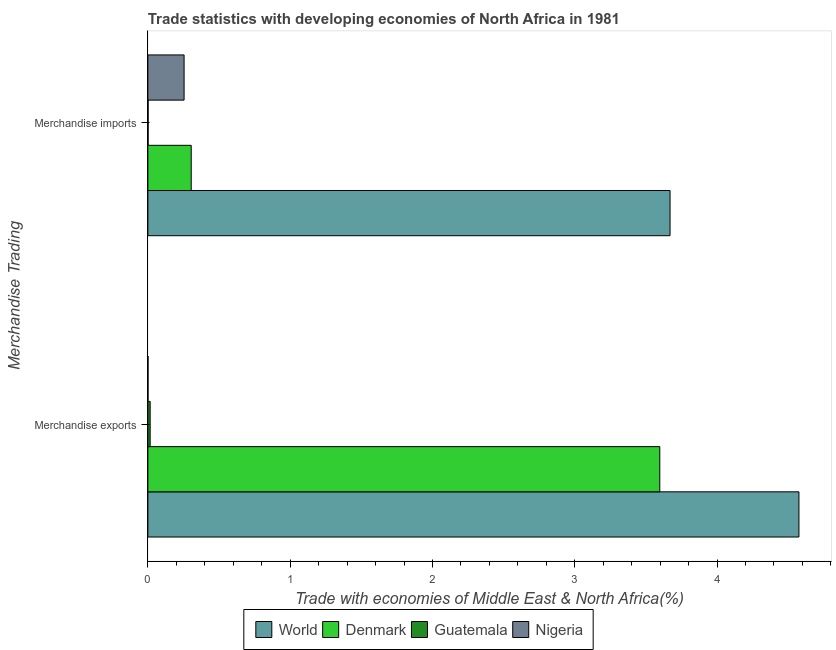How many groups of bars are there?
Provide a succinct answer. 2. Are the number of bars on each tick of the Y-axis equal?
Offer a terse response. Yes. How many bars are there on the 1st tick from the bottom?
Your answer should be very brief. 4. What is the label of the 2nd group of bars from the top?
Ensure brevity in your answer.  Merchandise exports. What is the merchandise exports in World?
Offer a terse response. 4.58. Across all countries, what is the maximum merchandise imports?
Make the answer very short. 3.67. Across all countries, what is the minimum merchandise exports?
Give a very brief answer. 0. In which country was the merchandise exports minimum?
Offer a very short reply. Nigeria. What is the total merchandise exports in the graph?
Provide a short and direct response. 8.19. What is the difference between the merchandise exports in Nigeria and that in World?
Your answer should be very brief. -4.57. What is the difference between the merchandise exports in Guatemala and the merchandise imports in Nigeria?
Offer a terse response. -0.24. What is the average merchandise exports per country?
Ensure brevity in your answer.  2.05. What is the difference between the merchandise imports and merchandise exports in Denmark?
Make the answer very short. -3.29. What is the ratio of the merchandise exports in Nigeria to that in Guatemala?
Offer a terse response. 0.06. What does the 3rd bar from the bottom in Merchandise imports represents?
Provide a succinct answer. Guatemala. How many bars are there?
Provide a succinct answer. 8. Does the graph contain any zero values?
Keep it short and to the point. No. Does the graph contain grids?
Your response must be concise. No. What is the title of the graph?
Give a very brief answer. Trade statistics with developing economies of North Africa in 1981. What is the label or title of the X-axis?
Your answer should be very brief. Trade with economies of Middle East & North Africa(%). What is the label or title of the Y-axis?
Make the answer very short. Merchandise Trading. What is the Trade with economies of Middle East & North Africa(%) of World in Merchandise exports?
Provide a short and direct response. 4.58. What is the Trade with economies of Middle East & North Africa(%) in Denmark in Merchandise exports?
Provide a short and direct response. 3.6. What is the Trade with economies of Middle East & North Africa(%) of Guatemala in Merchandise exports?
Provide a short and direct response. 0.02. What is the Trade with economies of Middle East & North Africa(%) in Nigeria in Merchandise exports?
Keep it short and to the point. 0. What is the Trade with economies of Middle East & North Africa(%) of World in Merchandise imports?
Provide a succinct answer. 3.67. What is the Trade with economies of Middle East & North Africa(%) of Denmark in Merchandise imports?
Your answer should be very brief. 0.3. What is the Trade with economies of Middle East & North Africa(%) of Guatemala in Merchandise imports?
Your answer should be very brief. 0. What is the Trade with economies of Middle East & North Africa(%) in Nigeria in Merchandise imports?
Make the answer very short. 0.25. Across all Merchandise Trading, what is the maximum Trade with economies of Middle East & North Africa(%) in World?
Your response must be concise. 4.58. Across all Merchandise Trading, what is the maximum Trade with economies of Middle East & North Africa(%) of Denmark?
Keep it short and to the point. 3.6. Across all Merchandise Trading, what is the maximum Trade with economies of Middle East & North Africa(%) in Guatemala?
Ensure brevity in your answer.  0.02. Across all Merchandise Trading, what is the maximum Trade with economies of Middle East & North Africa(%) in Nigeria?
Provide a succinct answer. 0.25. Across all Merchandise Trading, what is the minimum Trade with economies of Middle East & North Africa(%) of World?
Make the answer very short. 3.67. Across all Merchandise Trading, what is the minimum Trade with economies of Middle East & North Africa(%) in Denmark?
Give a very brief answer. 0.3. Across all Merchandise Trading, what is the minimum Trade with economies of Middle East & North Africa(%) of Guatemala?
Ensure brevity in your answer.  0. Across all Merchandise Trading, what is the minimum Trade with economies of Middle East & North Africa(%) in Nigeria?
Your answer should be compact. 0. What is the total Trade with economies of Middle East & North Africa(%) of World in the graph?
Your answer should be very brief. 8.24. What is the total Trade with economies of Middle East & North Africa(%) in Denmark in the graph?
Your answer should be compact. 3.9. What is the total Trade with economies of Middle East & North Africa(%) of Guatemala in the graph?
Your response must be concise. 0.02. What is the total Trade with economies of Middle East & North Africa(%) of Nigeria in the graph?
Provide a short and direct response. 0.26. What is the difference between the Trade with economies of Middle East & North Africa(%) in World in Merchandise exports and that in Merchandise imports?
Provide a succinct answer. 0.91. What is the difference between the Trade with economies of Middle East & North Africa(%) in Denmark in Merchandise exports and that in Merchandise imports?
Provide a succinct answer. 3.29. What is the difference between the Trade with economies of Middle East & North Africa(%) of Guatemala in Merchandise exports and that in Merchandise imports?
Your answer should be compact. 0.01. What is the difference between the Trade with economies of Middle East & North Africa(%) of Nigeria in Merchandise exports and that in Merchandise imports?
Give a very brief answer. -0.25. What is the difference between the Trade with economies of Middle East & North Africa(%) in World in Merchandise exports and the Trade with economies of Middle East & North Africa(%) in Denmark in Merchandise imports?
Offer a terse response. 4.27. What is the difference between the Trade with economies of Middle East & North Africa(%) of World in Merchandise exports and the Trade with economies of Middle East & North Africa(%) of Guatemala in Merchandise imports?
Offer a terse response. 4.57. What is the difference between the Trade with economies of Middle East & North Africa(%) of World in Merchandise exports and the Trade with economies of Middle East & North Africa(%) of Nigeria in Merchandise imports?
Offer a very short reply. 4.32. What is the difference between the Trade with economies of Middle East & North Africa(%) of Denmark in Merchandise exports and the Trade with economies of Middle East & North Africa(%) of Guatemala in Merchandise imports?
Give a very brief answer. 3.6. What is the difference between the Trade with economies of Middle East & North Africa(%) of Denmark in Merchandise exports and the Trade with economies of Middle East & North Africa(%) of Nigeria in Merchandise imports?
Offer a very short reply. 3.34. What is the difference between the Trade with economies of Middle East & North Africa(%) in Guatemala in Merchandise exports and the Trade with economies of Middle East & North Africa(%) in Nigeria in Merchandise imports?
Keep it short and to the point. -0.24. What is the average Trade with economies of Middle East & North Africa(%) in World per Merchandise Trading?
Your answer should be very brief. 4.12. What is the average Trade with economies of Middle East & North Africa(%) in Denmark per Merchandise Trading?
Your answer should be very brief. 1.95. What is the average Trade with economies of Middle East & North Africa(%) in Guatemala per Merchandise Trading?
Offer a very short reply. 0.01. What is the average Trade with economies of Middle East & North Africa(%) in Nigeria per Merchandise Trading?
Your answer should be very brief. 0.13. What is the difference between the Trade with economies of Middle East & North Africa(%) of World and Trade with economies of Middle East & North Africa(%) of Guatemala in Merchandise exports?
Your answer should be very brief. 4.56. What is the difference between the Trade with economies of Middle East & North Africa(%) in World and Trade with economies of Middle East & North Africa(%) in Nigeria in Merchandise exports?
Provide a succinct answer. 4.57. What is the difference between the Trade with economies of Middle East & North Africa(%) of Denmark and Trade with economies of Middle East & North Africa(%) of Guatemala in Merchandise exports?
Provide a succinct answer. 3.58. What is the difference between the Trade with economies of Middle East & North Africa(%) in Denmark and Trade with economies of Middle East & North Africa(%) in Nigeria in Merchandise exports?
Your response must be concise. 3.6. What is the difference between the Trade with economies of Middle East & North Africa(%) of Guatemala and Trade with economies of Middle East & North Africa(%) of Nigeria in Merchandise exports?
Provide a short and direct response. 0.01. What is the difference between the Trade with economies of Middle East & North Africa(%) in World and Trade with economies of Middle East & North Africa(%) in Denmark in Merchandise imports?
Provide a succinct answer. 3.36. What is the difference between the Trade with economies of Middle East & North Africa(%) of World and Trade with economies of Middle East & North Africa(%) of Guatemala in Merchandise imports?
Your response must be concise. 3.67. What is the difference between the Trade with economies of Middle East & North Africa(%) of World and Trade with economies of Middle East & North Africa(%) of Nigeria in Merchandise imports?
Make the answer very short. 3.42. What is the difference between the Trade with economies of Middle East & North Africa(%) of Denmark and Trade with economies of Middle East & North Africa(%) of Guatemala in Merchandise imports?
Provide a succinct answer. 0.3. What is the difference between the Trade with economies of Middle East & North Africa(%) in Denmark and Trade with economies of Middle East & North Africa(%) in Nigeria in Merchandise imports?
Ensure brevity in your answer.  0.05. What is the difference between the Trade with economies of Middle East & North Africa(%) in Guatemala and Trade with economies of Middle East & North Africa(%) in Nigeria in Merchandise imports?
Give a very brief answer. -0.25. What is the ratio of the Trade with economies of Middle East & North Africa(%) of World in Merchandise exports to that in Merchandise imports?
Offer a very short reply. 1.25. What is the ratio of the Trade with economies of Middle East & North Africa(%) in Denmark in Merchandise exports to that in Merchandise imports?
Your response must be concise. 11.81. What is the ratio of the Trade with economies of Middle East & North Africa(%) of Guatemala in Merchandise exports to that in Merchandise imports?
Provide a succinct answer. 9.27. What is the ratio of the Trade with economies of Middle East & North Africa(%) in Nigeria in Merchandise exports to that in Merchandise imports?
Provide a succinct answer. 0. What is the difference between the highest and the second highest Trade with economies of Middle East & North Africa(%) in World?
Make the answer very short. 0.91. What is the difference between the highest and the second highest Trade with economies of Middle East & North Africa(%) of Denmark?
Your answer should be very brief. 3.29. What is the difference between the highest and the second highest Trade with economies of Middle East & North Africa(%) of Guatemala?
Your response must be concise. 0.01. What is the difference between the highest and the second highest Trade with economies of Middle East & North Africa(%) in Nigeria?
Provide a short and direct response. 0.25. What is the difference between the highest and the lowest Trade with economies of Middle East & North Africa(%) in World?
Make the answer very short. 0.91. What is the difference between the highest and the lowest Trade with economies of Middle East & North Africa(%) of Denmark?
Ensure brevity in your answer.  3.29. What is the difference between the highest and the lowest Trade with economies of Middle East & North Africa(%) in Guatemala?
Your answer should be very brief. 0.01. What is the difference between the highest and the lowest Trade with economies of Middle East & North Africa(%) in Nigeria?
Ensure brevity in your answer.  0.25. 